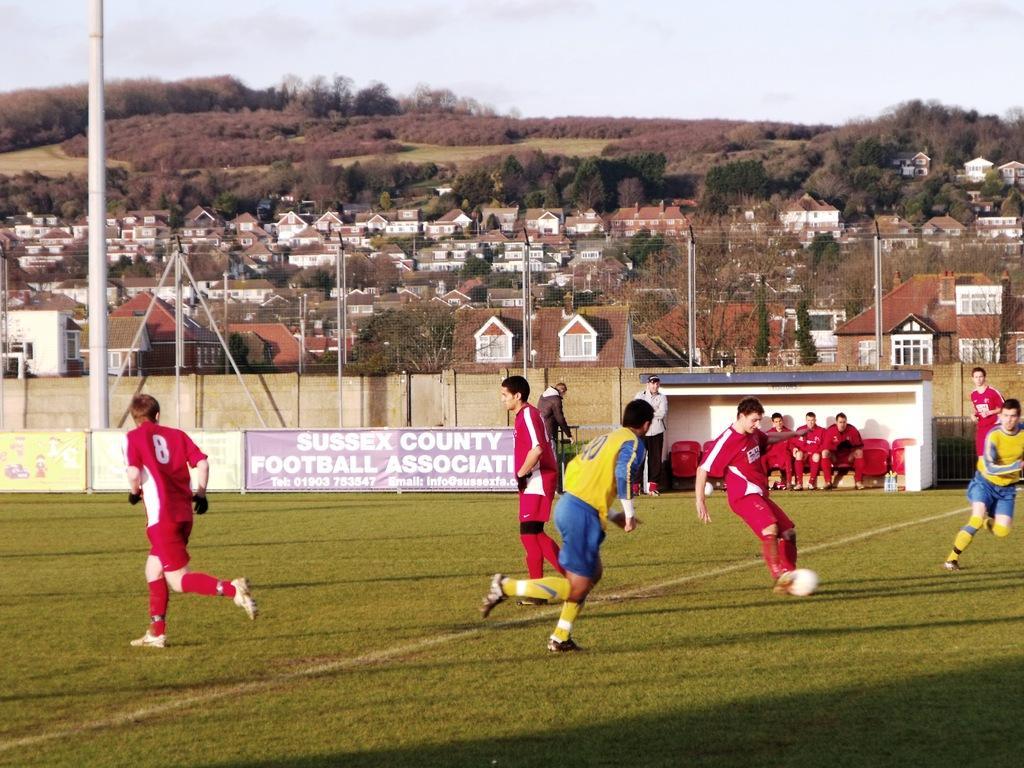Can you describe this image briefly? On the ground there are six people playing a football. There are red color t-shirt and yellow color t-shirt people. And in a background there are red color t-shirt people are sitting on the red color chair. And we can see a poster. In the background we can see houses, trees, hills. Into the left side there is a pole. 